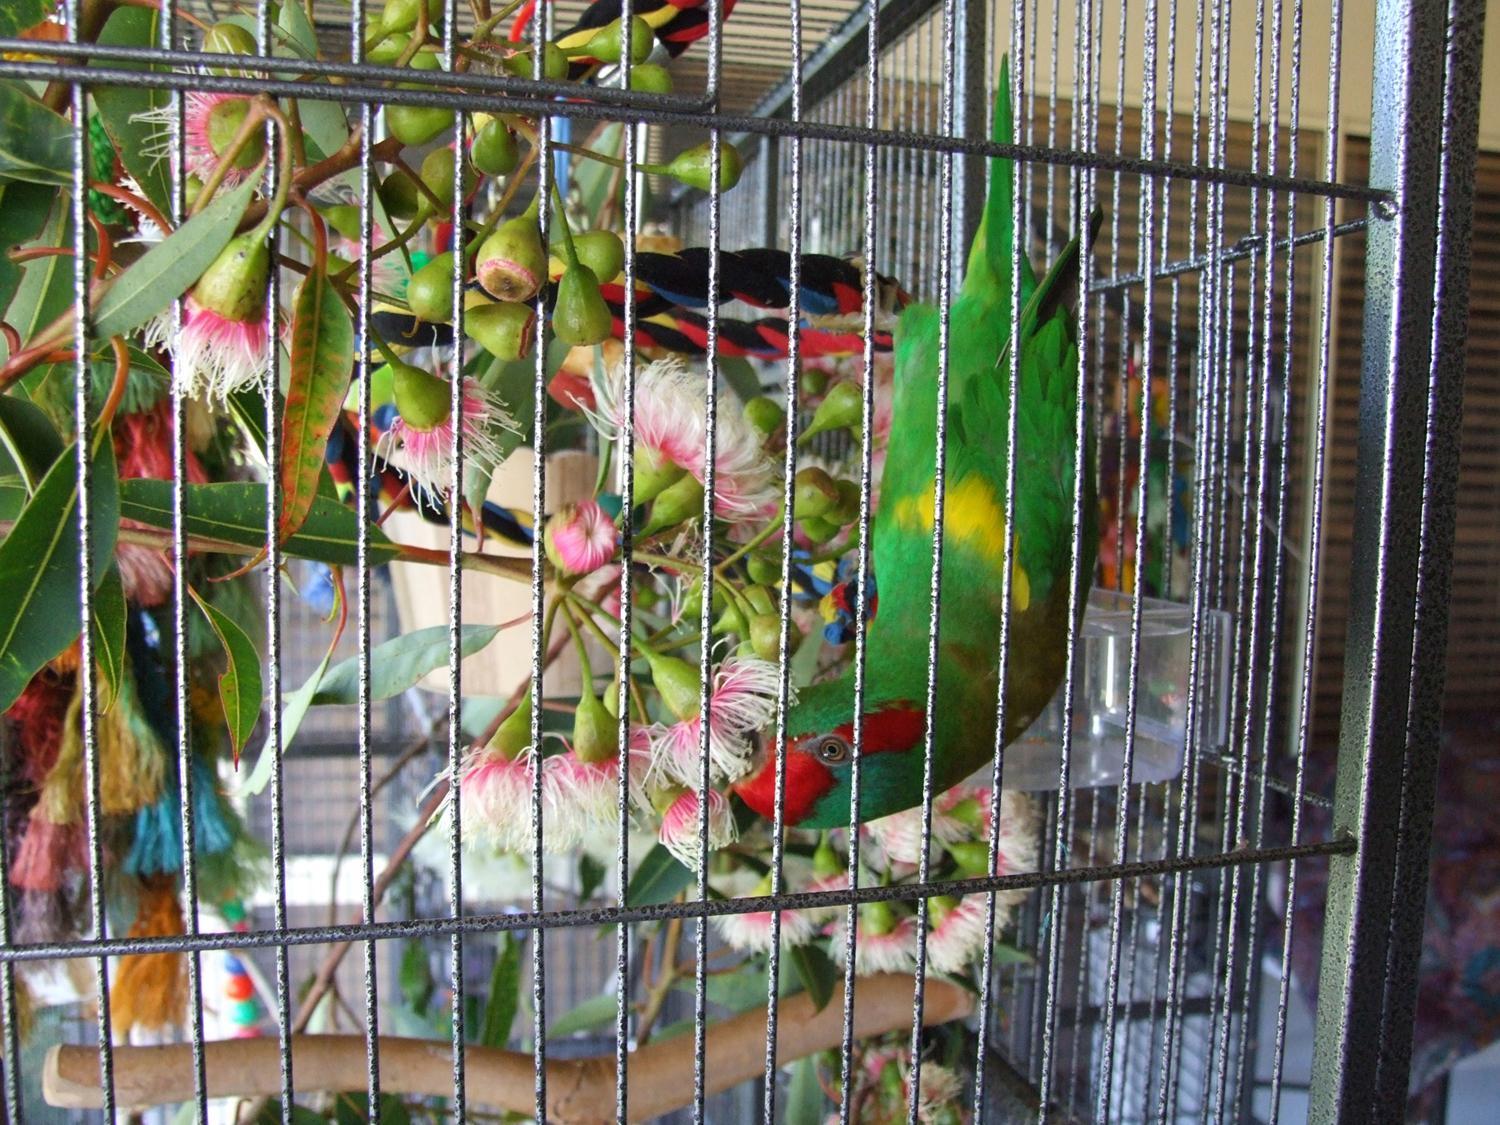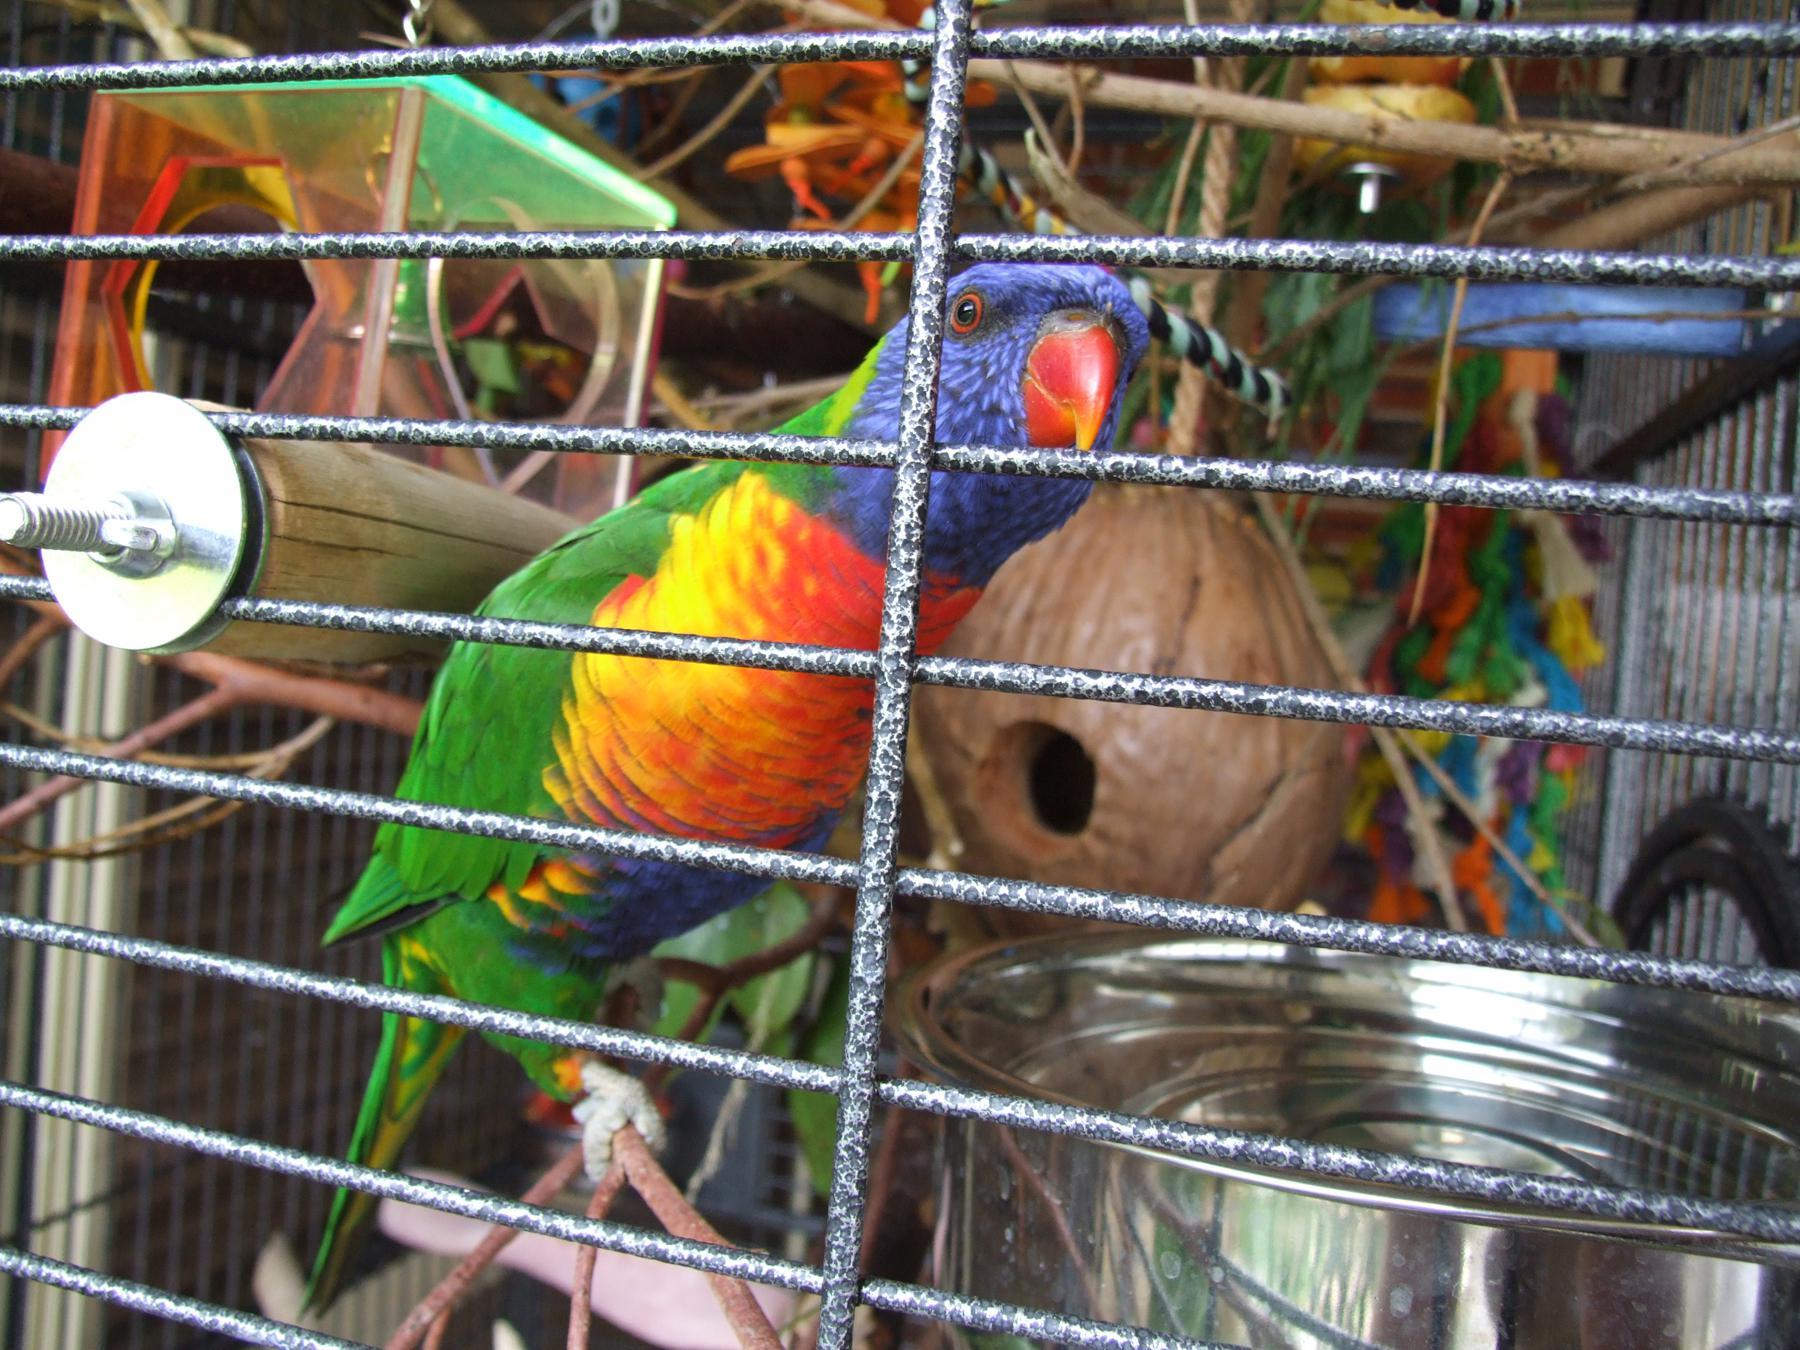The first image is the image on the left, the second image is the image on the right. Analyze the images presented: Is the assertion "Each image features at least one bird and a wire bird cage." valid? Answer yes or no. Yes. The first image is the image on the left, the second image is the image on the right. Evaluate the accuracy of this statement regarding the images: "A green bird is sitting in a cage in the image on the left.". Is it true? Answer yes or no. Yes. 